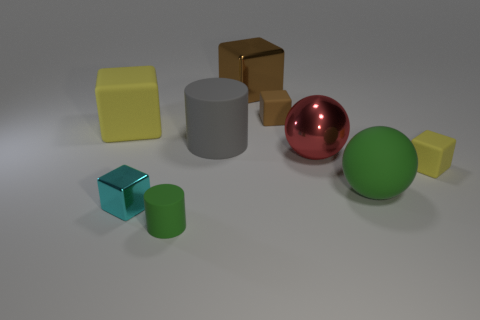Are the brown cube that is right of the large brown metallic thing and the tiny cube that is on the left side of the gray matte cylinder made of the same material?
Provide a succinct answer. No. There is a green object that is the same shape as the large gray thing; what is its size?
Offer a very short reply. Small. What is the large brown thing made of?
Offer a terse response. Metal. The tiny block to the left of the shiny block that is behind the tiny thing that is to the right of the small brown matte object is made of what material?
Your answer should be compact. Metal. The green cylinder is what size?
Keep it short and to the point. Small. Is the number of yellow objects on the right side of the brown metal thing less than the number of green rubber cylinders?
Provide a succinct answer. No. Do the red shiny ball and the rubber ball have the same size?
Your answer should be compact. Yes. There is a big block that is the same material as the green ball; what color is it?
Give a very brief answer. Yellow. Is the number of large rubber spheres that are on the right side of the big gray object less than the number of large balls that are on the right side of the big yellow matte cube?
Offer a terse response. Yes. What number of matte cylinders are the same color as the matte sphere?
Offer a terse response. 1. 